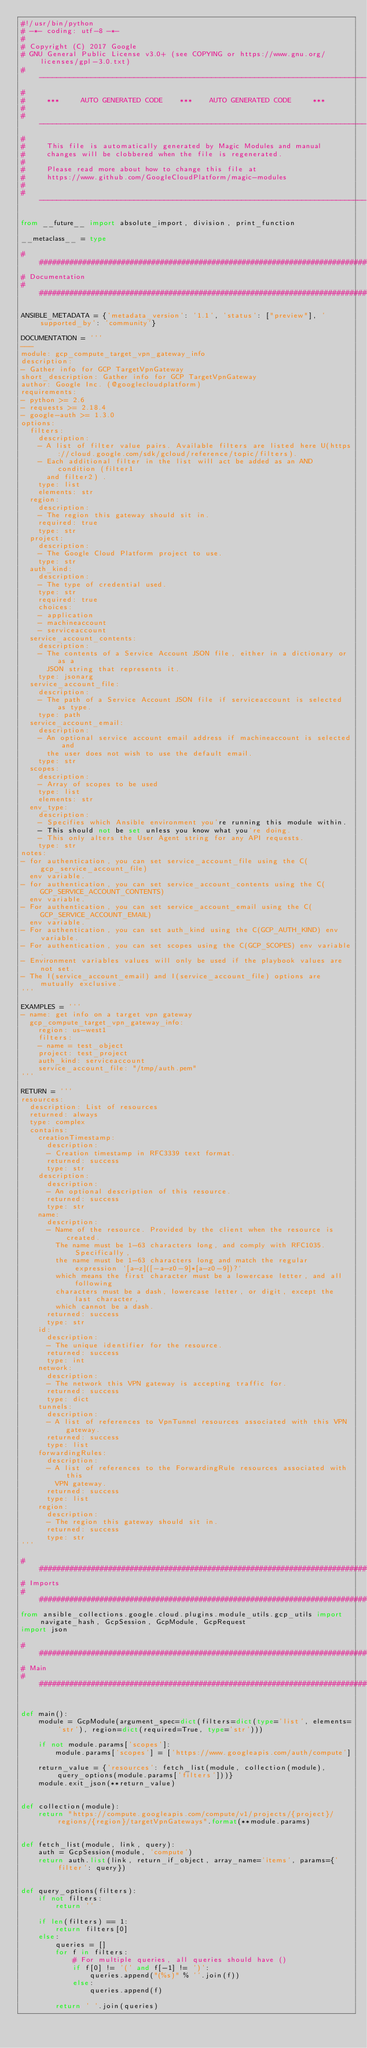<code> <loc_0><loc_0><loc_500><loc_500><_Python_>#!/usr/bin/python
# -*- coding: utf-8 -*-
#
# Copyright (C) 2017 Google
# GNU General Public License v3.0+ (see COPYING or https://www.gnu.org/licenses/gpl-3.0.txt)
# ----------------------------------------------------------------------------
#
#     ***     AUTO GENERATED CODE    ***    AUTO GENERATED CODE     ***
#
# ----------------------------------------------------------------------------
#
#     This file is automatically generated by Magic Modules and manual
#     changes will be clobbered when the file is regenerated.
#
#     Please read more about how to change this file at
#     https://www.github.com/GoogleCloudPlatform/magic-modules
#
# ----------------------------------------------------------------------------

from __future__ import absolute_import, division, print_function

__metaclass__ = type

################################################################################
# Documentation
################################################################################

ANSIBLE_METADATA = {'metadata_version': '1.1', 'status': ["preview"], 'supported_by': 'community'}

DOCUMENTATION = '''
---
module: gcp_compute_target_vpn_gateway_info
description:
- Gather info for GCP TargetVpnGateway
short_description: Gather info for GCP TargetVpnGateway
author: Google Inc. (@googlecloudplatform)
requirements:
- python >= 2.6
- requests >= 2.18.4
- google-auth >= 1.3.0
options:
  filters:
    description:
    - A list of filter value pairs. Available filters are listed here U(https://cloud.google.com/sdk/gcloud/reference/topic/filters).
    - Each additional filter in the list will act be added as an AND condition (filter1
      and filter2) .
    type: list
    elements: str
  region:
    description:
    - The region this gateway should sit in.
    required: true
    type: str
  project:
    description:
    - The Google Cloud Platform project to use.
    type: str
  auth_kind:
    description:
    - The type of credential used.
    type: str
    required: true
    choices:
    - application
    - machineaccount
    - serviceaccount
  service_account_contents:
    description:
    - The contents of a Service Account JSON file, either in a dictionary or as a
      JSON string that represents it.
    type: jsonarg
  service_account_file:
    description:
    - The path of a Service Account JSON file if serviceaccount is selected as type.
    type: path
  service_account_email:
    description:
    - An optional service account email address if machineaccount is selected and
      the user does not wish to use the default email.
    type: str
  scopes:
    description:
    - Array of scopes to be used
    type: list
    elements: str
  env_type:
    description:
    - Specifies which Ansible environment you're running this module within.
    - This should not be set unless you know what you're doing.
    - This only alters the User Agent string for any API requests.
    type: str
notes:
- for authentication, you can set service_account_file using the C(gcp_service_account_file)
  env variable.
- for authentication, you can set service_account_contents using the C(GCP_SERVICE_ACCOUNT_CONTENTS)
  env variable.
- For authentication, you can set service_account_email using the C(GCP_SERVICE_ACCOUNT_EMAIL)
  env variable.
- For authentication, you can set auth_kind using the C(GCP_AUTH_KIND) env variable.
- For authentication, you can set scopes using the C(GCP_SCOPES) env variable.
- Environment variables values will only be used if the playbook values are not set.
- The I(service_account_email) and I(service_account_file) options are mutually exclusive.
'''

EXAMPLES = '''
- name: get info on a target vpn gateway
  gcp_compute_target_vpn_gateway_info:
    region: us-west1
    filters:
    - name = test_object
    project: test_project
    auth_kind: serviceaccount
    service_account_file: "/tmp/auth.pem"
'''

RETURN = '''
resources:
  description: List of resources
  returned: always
  type: complex
  contains:
    creationTimestamp:
      description:
      - Creation timestamp in RFC3339 text format.
      returned: success
      type: str
    description:
      description:
      - An optional description of this resource.
      returned: success
      type: str
    name:
      description:
      - Name of the resource. Provided by the client when the resource is created.
        The name must be 1-63 characters long, and comply with RFC1035. Specifically,
        the name must be 1-63 characters long and match the regular expression `[a-z]([-a-z0-9]*[a-z0-9])?`
        which means the first character must be a lowercase letter, and all following
        characters must be a dash, lowercase letter, or digit, except the last character,
        which cannot be a dash.
      returned: success
      type: str
    id:
      description:
      - The unique identifier for the resource.
      returned: success
      type: int
    network:
      description:
      - The network this VPN gateway is accepting traffic for.
      returned: success
      type: dict
    tunnels:
      description:
      - A list of references to VpnTunnel resources associated with this VPN gateway.
      returned: success
      type: list
    forwardingRules:
      description:
      - A list of references to the ForwardingRule resources associated with this
        VPN gateway.
      returned: success
      type: list
    region:
      description:
      - The region this gateway should sit in.
      returned: success
      type: str
'''

################################################################################
# Imports
################################################################################
from ansible_collections.google.cloud.plugins.module_utils.gcp_utils import navigate_hash, GcpSession, GcpModule, GcpRequest
import json

################################################################################
# Main
################################################################################


def main():
    module = GcpModule(argument_spec=dict(filters=dict(type='list', elements='str'), region=dict(required=True, type='str')))

    if not module.params['scopes']:
        module.params['scopes'] = ['https://www.googleapis.com/auth/compute']

    return_value = {'resources': fetch_list(module, collection(module), query_options(module.params['filters']))}
    module.exit_json(**return_value)


def collection(module):
    return "https://compute.googleapis.com/compute/v1/projects/{project}/regions/{region}/targetVpnGateways".format(**module.params)


def fetch_list(module, link, query):
    auth = GcpSession(module, 'compute')
    return auth.list(link, return_if_object, array_name='items', params={'filter': query})


def query_options(filters):
    if not filters:
        return ''

    if len(filters) == 1:
        return filters[0]
    else:
        queries = []
        for f in filters:
            # For multiple queries, all queries should have ()
            if f[0] != '(' and f[-1] != ')':
                queries.append("(%s)" % ''.join(f))
            else:
                queries.append(f)

        return ' '.join(queries)

</code> 